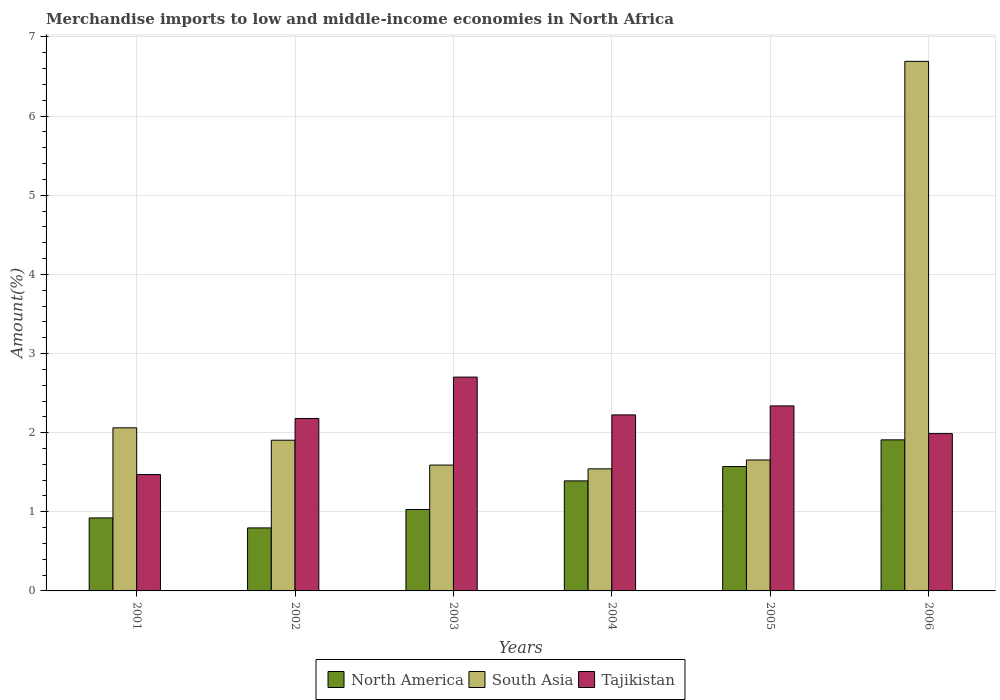How many groups of bars are there?
Ensure brevity in your answer.  6. In how many cases, is the number of bars for a given year not equal to the number of legend labels?
Your answer should be very brief. 0. What is the percentage of amount earned from merchandise imports in North America in 2005?
Make the answer very short. 1.57. Across all years, what is the maximum percentage of amount earned from merchandise imports in South Asia?
Offer a terse response. 6.69. Across all years, what is the minimum percentage of amount earned from merchandise imports in Tajikistan?
Make the answer very short. 1.47. In which year was the percentage of amount earned from merchandise imports in South Asia minimum?
Ensure brevity in your answer.  2004. What is the total percentage of amount earned from merchandise imports in South Asia in the graph?
Your response must be concise. 15.45. What is the difference between the percentage of amount earned from merchandise imports in North America in 2002 and that in 2003?
Provide a short and direct response. -0.23. What is the difference between the percentage of amount earned from merchandise imports in North America in 2003 and the percentage of amount earned from merchandise imports in South Asia in 2002?
Ensure brevity in your answer.  -0.88. What is the average percentage of amount earned from merchandise imports in Tajikistan per year?
Your answer should be very brief. 2.15. In the year 2001, what is the difference between the percentage of amount earned from merchandise imports in Tajikistan and percentage of amount earned from merchandise imports in South Asia?
Provide a short and direct response. -0.59. In how many years, is the percentage of amount earned from merchandise imports in North America greater than 0.6000000000000001 %?
Provide a short and direct response. 6. What is the ratio of the percentage of amount earned from merchandise imports in South Asia in 2002 to that in 2005?
Keep it short and to the point. 1.15. Is the difference between the percentage of amount earned from merchandise imports in Tajikistan in 2003 and 2004 greater than the difference between the percentage of amount earned from merchandise imports in South Asia in 2003 and 2004?
Make the answer very short. Yes. What is the difference between the highest and the second highest percentage of amount earned from merchandise imports in Tajikistan?
Provide a succinct answer. 0.36. What is the difference between the highest and the lowest percentage of amount earned from merchandise imports in North America?
Keep it short and to the point. 1.11. What does the 2nd bar from the left in 2002 represents?
Offer a very short reply. South Asia. What does the 2nd bar from the right in 2001 represents?
Give a very brief answer. South Asia. How many bars are there?
Offer a very short reply. 18. How many years are there in the graph?
Give a very brief answer. 6. Are the values on the major ticks of Y-axis written in scientific E-notation?
Give a very brief answer. No. Does the graph contain any zero values?
Your answer should be very brief. No. How many legend labels are there?
Your response must be concise. 3. How are the legend labels stacked?
Your answer should be very brief. Horizontal. What is the title of the graph?
Give a very brief answer. Merchandise imports to low and middle-income economies in North Africa. Does "Small states" appear as one of the legend labels in the graph?
Make the answer very short. No. What is the label or title of the X-axis?
Provide a short and direct response. Years. What is the label or title of the Y-axis?
Keep it short and to the point. Amount(%). What is the Amount(%) of North America in 2001?
Give a very brief answer. 0.92. What is the Amount(%) in South Asia in 2001?
Give a very brief answer. 2.06. What is the Amount(%) of Tajikistan in 2001?
Your response must be concise. 1.47. What is the Amount(%) in North America in 2002?
Keep it short and to the point. 0.8. What is the Amount(%) of South Asia in 2002?
Keep it short and to the point. 1.9. What is the Amount(%) in Tajikistan in 2002?
Your answer should be very brief. 2.18. What is the Amount(%) in North America in 2003?
Offer a very short reply. 1.03. What is the Amount(%) in South Asia in 2003?
Keep it short and to the point. 1.59. What is the Amount(%) in Tajikistan in 2003?
Ensure brevity in your answer.  2.7. What is the Amount(%) of North America in 2004?
Offer a terse response. 1.39. What is the Amount(%) in South Asia in 2004?
Ensure brevity in your answer.  1.54. What is the Amount(%) in Tajikistan in 2004?
Provide a succinct answer. 2.22. What is the Amount(%) in North America in 2005?
Offer a terse response. 1.57. What is the Amount(%) of South Asia in 2005?
Make the answer very short. 1.65. What is the Amount(%) in Tajikistan in 2005?
Keep it short and to the point. 2.34. What is the Amount(%) in North America in 2006?
Give a very brief answer. 1.91. What is the Amount(%) in South Asia in 2006?
Keep it short and to the point. 6.69. What is the Amount(%) of Tajikistan in 2006?
Provide a succinct answer. 1.99. Across all years, what is the maximum Amount(%) of North America?
Offer a very short reply. 1.91. Across all years, what is the maximum Amount(%) of South Asia?
Offer a terse response. 6.69. Across all years, what is the maximum Amount(%) of Tajikistan?
Offer a terse response. 2.7. Across all years, what is the minimum Amount(%) of North America?
Your answer should be compact. 0.8. Across all years, what is the minimum Amount(%) in South Asia?
Keep it short and to the point. 1.54. Across all years, what is the minimum Amount(%) in Tajikistan?
Offer a terse response. 1.47. What is the total Amount(%) in North America in the graph?
Your response must be concise. 7.62. What is the total Amount(%) of South Asia in the graph?
Offer a terse response. 15.45. What is the total Amount(%) of Tajikistan in the graph?
Offer a very short reply. 12.9. What is the difference between the Amount(%) of North America in 2001 and that in 2002?
Your answer should be compact. 0.13. What is the difference between the Amount(%) in South Asia in 2001 and that in 2002?
Make the answer very short. 0.16. What is the difference between the Amount(%) of Tajikistan in 2001 and that in 2002?
Make the answer very short. -0.71. What is the difference between the Amount(%) in North America in 2001 and that in 2003?
Ensure brevity in your answer.  -0.11. What is the difference between the Amount(%) of South Asia in 2001 and that in 2003?
Make the answer very short. 0.47. What is the difference between the Amount(%) in Tajikistan in 2001 and that in 2003?
Provide a short and direct response. -1.23. What is the difference between the Amount(%) in North America in 2001 and that in 2004?
Make the answer very short. -0.47. What is the difference between the Amount(%) in South Asia in 2001 and that in 2004?
Keep it short and to the point. 0.52. What is the difference between the Amount(%) in Tajikistan in 2001 and that in 2004?
Offer a terse response. -0.75. What is the difference between the Amount(%) in North America in 2001 and that in 2005?
Provide a short and direct response. -0.65. What is the difference between the Amount(%) of South Asia in 2001 and that in 2005?
Your answer should be very brief. 0.41. What is the difference between the Amount(%) of Tajikistan in 2001 and that in 2005?
Provide a short and direct response. -0.87. What is the difference between the Amount(%) of North America in 2001 and that in 2006?
Provide a succinct answer. -0.99. What is the difference between the Amount(%) of South Asia in 2001 and that in 2006?
Your answer should be compact. -4.63. What is the difference between the Amount(%) of Tajikistan in 2001 and that in 2006?
Your answer should be very brief. -0.52. What is the difference between the Amount(%) in North America in 2002 and that in 2003?
Your response must be concise. -0.23. What is the difference between the Amount(%) of South Asia in 2002 and that in 2003?
Ensure brevity in your answer.  0.31. What is the difference between the Amount(%) of Tajikistan in 2002 and that in 2003?
Ensure brevity in your answer.  -0.52. What is the difference between the Amount(%) in North America in 2002 and that in 2004?
Provide a short and direct response. -0.59. What is the difference between the Amount(%) of South Asia in 2002 and that in 2004?
Offer a terse response. 0.36. What is the difference between the Amount(%) in Tajikistan in 2002 and that in 2004?
Your answer should be compact. -0.05. What is the difference between the Amount(%) of North America in 2002 and that in 2005?
Provide a short and direct response. -0.78. What is the difference between the Amount(%) in South Asia in 2002 and that in 2005?
Your response must be concise. 0.25. What is the difference between the Amount(%) of Tajikistan in 2002 and that in 2005?
Make the answer very short. -0.16. What is the difference between the Amount(%) of North America in 2002 and that in 2006?
Offer a terse response. -1.11. What is the difference between the Amount(%) in South Asia in 2002 and that in 2006?
Make the answer very short. -4.79. What is the difference between the Amount(%) of Tajikistan in 2002 and that in 2006?
Offer a very short reply. 0.19. What is the difference between the Amount(%) of North America in 2003 and that in 2004?
Your response must be concise. -0.36. What is the difference between the Amount(%) of South Asia in 2003 and that in 2004?
Your answer should be compact. 0.05. What is the difference between the Amount(%) in Tajikistan in 2003 and that in 2004?
Ensure brevity in your answer.  0.48. What is the difference between the Amount(%) in North America in 2003 and that in 2005?
Your answer should be very brief. -0.54. What is the difference between the Amount(%) of South Asia in 2003 and that in 2005?
Make the answer very short. -0.06. What is the difference between the Amount(%) in Tajikistan in 2003 and that in 2005?
Your answer should be compact. 0.36. What is the difference between the Amount(%) in North America in 2003 and that in 2006?
Your answer should be very brief. -0.88. What is the difference between the Amount(%) of South Asia in 2003 and that in 2006?
Provide a short and direct response. -5.1. What is the difference between the Amount(%) in Tajikistan in 2003 and that in 2006?
Make the answer very short. 0.71. What is the difference between the Amount(%) of North America in 2004 and that in 2005?
Keep it short and to the point. -0.18. What is the difference between the Amount(%) in South Asia in 2004 and that in 2005?
Your answer should be compact. -0.11. What is the difference between the Amount(%) of Tajikistan in 2004 and that in 2005?
Your answer should be very brief. -0.11. What is the difference between the Amount(%) of North America in 2004 and that in 2006?
Your answer should be compact. -0.52. What is the difference between the Amount(%) in South Asia in 2004 and that in 2006?
Provide a short and direct response. -5.15. What is the difference between the Amount(%) of Tajikistan in 2004 and that in 2006?
Give a very brief answer. 0.24. What is the difference between the Amount(%) in North America in 2005 and that in 2006?
Provide a succinct answer. -0.34. What is the difference between the Amount(%) in South Asia in 2005 and that in 2006?
Your answer should be compact. -5.04. What is the difference between the Amount(%) of Tajikistan in 2005 and that in 2006?
Your answer should be compact. 0.35. What is the difference between the Amount(%) of North America in 2001 and the Amount(%) of South Asia in 2002?
Provide a short and direct response. -0.98. What is the difference between the Amount(%) of North America in 2001 and the Amount(%) of Tajikistan in 2002?
Your answer should be compact. -1.26. What is the difference between the Amount(%) of South Asia in 2001 and the Amount(%) of Tajikistan in 2002?
Provide a succinct answer. -0.12. What is the difference between the Amount(%) in North America in 2001 and the Amount(%) in South Asia in 2003?
Make the answer very short. -0.67. What is the difference between the Amount(%) of North America in 2001 and the Amount(%) of Tajikistan in 2003?
Make the answer very short. -1.78. What is the difference between the Amount(%) in South Asia in 2001 and the Amount(%) in Tajikistan in 2003?
Make the answer very short. -0.64. What is the difference between the Amount(%) of North America in 2001 and the Amount(%) of South Asia in 2004?
Your response must be concise. -0.62. What is the difference between the Amount(%) of North America in 2001 and the Amount(%) of Tajikistan in 2004?
Offer a terse response. -1.3. What is the difference between the Amount(%) of South Asia in 2001 and the Amount(%) of Tajikistan in 2004?
Provide a short and direct response. -0.16. What is the difference between the Amount(%) of North America in 2001 and the Amount(%) of South Asia in 2005?
Offer a very short reply. -0.73. What is the difference between the Amount(%) in North America in 2001 and the Amount(%) in Tajikistan in 2005?
Offer a terse response. -1.42. What is the difference between the Amount(%) of South Asia in 2001 and the Amount(%) of Tajikistan in 2005?
Offer a terse response. -0.28. What is the difference between the Amount(%) in North America in 2001 and the Amount(%) in South Asia in 2006?
Your answer should be very brief. -5.77. What is the difference between the Amount(%) of North America in 2001 and the Amount(%) of Tajikistan in 2006?
Provide a succinct answer. -1.07. What is the difference between the Amount(%) in South Asia in 2001 and the Amount(%) in Tajikistan in 2006?
Your answer should be very brief. 0.07. What is the difference between the Amount(%) in North America in 2002 and the Amount(%) in South Asia in 2003?
Ensure brevity in your answer.  -0.79. What is the difference between the Amount(%) of North America in 2002 and the Amount(%) of Tajikistan in 2003?
Make the answer very short. -1.91. What is the difference between the Amount(%) in South Asia in 2002 and the Amount(%) in Tajikistan in 2003?
Ensure brevity in your answer.  -0.8. What is the difference between the Amount(%) in North America in 2002 and the Amount(%) in South Asia in 2004?
Offer a very short reply. -0.75. What is the difference between the Amount(%) of North America in 2002 and the Amount(%) of Tajikistan in 2004?
Offer a very short reply. -1.43. What is the difference between the Amount(%) of South Asia in 2002 and the Amount(%) of Tajikistan in 2004?
Provide a succinct answer. -0.32. What is the difference between the Amount(%) in North America in 2002 and the Amount(%) in South Asia in 2005?
Your response must be concise. -0.86. What is the difference between the Amount(%) in North America in 2002 and the Amount(%) in Tajikistan in 2005?
Ensure brevity in your answer.  -1.54. What is the difference between the Amount(%) of South Asia in 2002 and the Amount(%) of Tajikistan in 2005?
Keep it short and to the point. -0.43. What is the difference between the Amount(%) in North America in 2002 and the Amount(%) in South Asia in 2006?
Ensure brevity in your answer.  -5.9. What is the difference between the Amount(%) in North America in 2002 and the Amount(%) in Tajikistan in 2006?
Give a very brief answer. -1.19. What is the difference between the Amount(%) of South Asia in 2002 and the Amount(%) of Tajikistan in 2006?
Offer a terse response. -0.08. What is the difference between the Amount(%) of North America in 2003 and the Amount(%) of South Asia in 2004?
Your response must be concise. -0.51. What is the difference between the Amount(%) in North America in 2003 and the Amount(%) in Tajikistan in 2004?
Make the answer very short. -1.2. What is the difference between the Amount(%) in South Asia in 2003 and the Amount(%) in Tajikistan in 2004?
Make the answer very short. -0.63. What is the difference between the Amount(%) in North America in 2003 and the Amount(%) in South Asia in 2005?
Provide a short and direct response. -0.63. What is the difference between the Amount(%) in North America in 2003 and the Amount(%) in Tajikistan in 2005?
Ensure brevity in your answer.  -1.31. What is the difference between the Amount(%) in South Asia in 2003 and the Amount(%) in Tajikistan in 2005?
Offer a very short reply. -0.75. What is the difference between the Amount(%) of North America in 2003 and the Amount(%) of South Asia in 2006?
Offer a very short reply. -5.66. What is the difference between the Amount(%) of North America in 2003 and the Amount(%) of Tajikistan in 2006?
Offer a terse response. -0.96. What is the difference between the Amount(%) in South Asia in 2003 and the Amount(%) in Tajikistan in 2006?
Your response must be concise. -0.4. What is the difference between the Amount(%) in North America in 2004 and the Amount(%) in South Asia in 2005?
Ensure brevity in your answer.  -0.26. What is the difference between the Amount(%) of North America in 2004 and the Amount(%) of Tajikistan in 2005?
Your answer should be very brief. -0.95. What is the difference between the Amount(%) of South Asia in 2004 and the Amount(%) of Tajikistan in 2005?
Provide a short and direct response. -0.8. What is the difference between the Amount(%) of North America in 2004 and the Amount(%) of South Asia in 2006?
Offer a terse response. -5.3. What is the difference between the Amount(%) in North America in 2004 and the Amount(%) in Tajikistan in 2006?
Offer a terse response. -0.6. What is the difference between the Amount(%) of South Asia in 2004 and the Amount(%) of Tajikistan in 2006?
Keep it short and to the point. -0.45. What is the difference between the Amount(%) of North America in 2005 and the Amount(%) of South Asia in 2006?
Provide a short and direct response. -5.12. What is the difference between the Amount(%) in North America in 2005 and the Amount(%) in Tajikistan in 2006?
Keep it short and to the point. -0.42. What is the difference between the Amount(%) of South Asia in 2005 and the Amount(%) of Tajikistan in 2006?
Give a very brief answer. -0.33. What is the average Amount(%) of North America per year?
Your response must be concise. 1.27. What is the average Amount(%) in South Asia per year?
Your answer should be very brief. 2.57. What is the average Amount(%) of Tajikistan per year?
Keep it short and to the point. 2.15. In the year 2001, what is the difference between the Amount(%) of North America and Amount(%) of South Asia?
Give a very brief answer. -1.14. In the year 2001, what is the difference between the Amount(%) in North America and Amount(%) in Tajikistan?
Keep it short and to the point. -0.55. In the year 2001, what is the difference between the Amount(%) of South Asia and Amount(%) of Tajikistan?
Provide a short and direct response. 0.59. In the year 2002, what is the difference between the Amount(%) of North America and Amount(%) of South Asia?
Give a very brief answer. -1.11. In the year 2002, what is the difference between the Amount(%) in North America and Amount(%) in Tajikistan?
Make the answer very short. -1.38. In the year 2002, what is the difference between the Amount(%) of South Asia and Amount(%) of Tajikistan?
Your answer should be very brief. -0.27. In the year 2003, what is the difference between the Amount(%) in North America and Amount(%) in South Asia?
Your answer should be very brief. -0.56. In the year 2003, what is the difference between the Amount(%) of North America and Amount(%) of Tajikistan?
Keep it short and to the point. -1.67. In the year 2003, what is the difference between the Amount(%) of South Asia and Amount(%) of Tajikistan?
Give a very brief answer. -1.11. In the year 2004, what is the difference between the Amount(%) of North America and Amount(%) of South Asia?
Offer a very short reply. -0.15. In the year 2004, what is the difference between the Amount(%) of North America and Amount(%) of Tajikistan?
Give a very brief answer. -0.83. In the year 2004, what is the difference between the Amount(%) in South Asia and Amount(%) in Tajikistan?
Keep it short and to the point. -0.68. In the year 2005, what is the difference between the Amount(%) in North America and Amount(%) in South Asia?
Ensure brevity in your answer.  -0.08. In the year 2005, what is the difference between the Amount(%) in North America and Amount(%) in Tajikistan?
Give a very brief answer. -0.77. In the year 2005, what is the difference between the Amount(%) in South Asia and Amount(%) in Tajikistan?
Provide a succinct answer. -0.68. In the year 2006, what is the difference between the Amount(%) of North America and Amount(%) of South Asia?
Your answer should be very brief. -4.78. In the year 2006, what is the difference between the Amount(%) of North America and Amount(%) of Tajikistan?
Ensure brevity in your answer.  -0.08. In the year 2006, what is the difference between the Amount(%) in South Asia and Amount(%) in Tajikistan?
Ensure brevity in your answer.  4.7. What is the ratio of the Amount(%) of North America in 2001 to that in 2002?
Provide a short and direct response. 1.16. What is the ratio of the Amount(%) of South Asia in 2001 to that in 2002?
Provide a short and direct response. 1.08. What is the ratio of the Amount(%) of Tajikistan in 2001 to that in 2002?
Offer a terse response. 0.67. What is the ratio of the Amount(%) of North America in 2001 to that in 2003?
Provide a short and direct response. 0.9. What is the ratio of the Amount(%) in South Asia in 2001 to that in 2003?
Your answer should be very brief. 1.3. What is the ratio of the Amount(%) of Tajikistan in 2001 to that in 2003?
Your answer should be very brief. 0.54. What is the ratio of the Amount(%) of North America in 2001 to that in 2004?
Provide a succinct answer. 0.66. What is the ratio of the Amount(%) in South Asia in 2001 to that in 2004?
Your answer should be compact. 1.34. What is the ratio of the Amount(%) of Tajikistan in 2001 to that in 2004?
Provide a short and direct response. 0.66. What is the ratio of the Amount(%) of North America in 2001 to that in 2005?
Give a very brief answer. 0.59. What is the ratio of the Amount(%) of South Asia in 2001 to that in 2005?
Provide a succinct answer. 1.25. What is the ratio of the Amount(%) of Tajikistan in 2001 to that in 2005?
Offer a terse response. 0.63. What is the ratio of the Amount(%) in North America in 2001 to that in 2006?
Provide a succinct answer. 0.48. What is the ratio of the Amount(%) in South Asia in 2001 to that in 2006?
Your answer should be very brief. 0.31. What is the ratio of the Amount(%) of Tajikistan in 2001 to that in 2006?
Provide a short and direct response. 0.74. What is the ratio of the Amount(%) in North America in 2002 to that in 2003?
Make the answer very short. 0.77. What is the ratio of the Amount(%) in South Asia in 2002 to that in 2003?
Provide a short and direct response. 1.2. What is the ratio of the Amount(%) of Tajikistan in 2002 to that in 2003?
Provide a short and direct response. 0.81. What is the ratio of the Amount(%) of North America in 2002 to that in 2004?
Make the answer very short. 0.57. What is the ratio of the Amount(%) in South Asia in 2002 to that in 2004?
Keep it short and to the point. 1.23. What is the ratio of the Amount(%) of Tajikistan in 2002 to that in 2004?
Your response must be concise. 0.98. What is the ratio of the Amount(%) of North America in 2002 to that in 2005?
Give a very brief answer. 0.51. What is the ratio of the Amount(%) of South Asia in 2002 to that in 2005?
Your answer should be very brief. 1.15. What is the ratio of the Amount(%) of Tajikistan in 2002 to that in 2005?
Your answer should be compact. 0.93. What is the ratio of the Amount(%) in North America in 2002 to that in 2006?
Your answer should be compact. 0.42. What is the ratio of the Amount(%) of South Asia in 2002 to that in 2006?
Provide a succinct answer. 0.28. What is the ratio of the Amount(%) of Tajikistan in 2002 to that in 2006?
Provide a short and direct response. 1.1. What is the ratio of the Amount(%) of North America in 2003 to that in 2004?
Provide a short and direct response. 0.74. What is the ratio of the Amount(%) in South Asia in 2003 to that in 2004?
Give a very brief answer. 1.03. What is the ratio of the Amount(%) in Tajikistan in 2003 to that in 2004?
Give a very brief answer. 1.21. What is the ratio of the Amount(%) in North America in 2003 to that in 2005?
Your answer should be very brief. 0.65. What is the ratio of the Amount(%) of South Asia in 2003 to that in 2005?
Offer a very short reply. 0.96. What is the ratio of the Amount(%) of Tajikistan in 2003 to that in 2005?
Provide a short and direct response. 1.16. What is the ratio of the Amount(%) in North America in 2003 to that in 2006?
Your response must be concise. 0.54. What is the ratio of the Amount(%) in South Asia in 2003 to that in 2006?
Provide a short and direct response. 0.24. What is the ratio of the Amount(%) in Tajikistan in 2003 to that in 2006?
Offer a terse response. 1.36. What is the ratio of the Amount(%) in North America in 2004 to that in 2005?
Keep it short and to the point. 0.88. What is the ratio of the Amount(%) in South Asia in 2004 to that in 2005?
Your answer should be very brief. 0.93. What is the ratio of the Amount(%) of Tajikistan in 2004 to that in 2005?
Offer a terse response. 0.95. What is the ratio of the Amount(%) of North America in 2004 to that in 2006?
Provide a succinct answer. 0.73. What is the ratio of the Amount(%) of South Asia in 2004 to that in 2006?
Keep it short and to the point. 0.23. What is the ratio of the Amount(%) in Tajikistan in 2004 to that in 2006?
Keep it short and to the point. 1.12. What is the ratio of the Amount(%) in North America in 2005 to that in 2006?
Provide a short and direct response. 0.82. What is the ratio of the Amount(%) of South Asia in 2005 to that in 2006?
Your response must be concise. 0.25. What is the ratio of the Amount(%) in Tajikistan in 2005 to that in 2006?
Ensure brevity in your answer.  1.18. What is the difference between the highest and the second highest Amount(%) of North America?
Provide a short and direct response. 0.34. What is the difference between the highest and the second highest Amount(%) in South Asia?
Make the answer very short. 4.63. What is the difference between the highest and the second highest Amount(%) in Tajikistan?
Offer a very short reply. 0.36. What is the difference between the highest and the lowest Amount(%) of North America?
Ensure brevity in your answer.  1.11. What is the difference between the highest and the lowest Amount(%) of South Asia?
Your answer should be very brief. 5.15. What is the difference between the highest and the lowest Amount(%) in Tajikistan?
Offer a terse response. 1.23. 